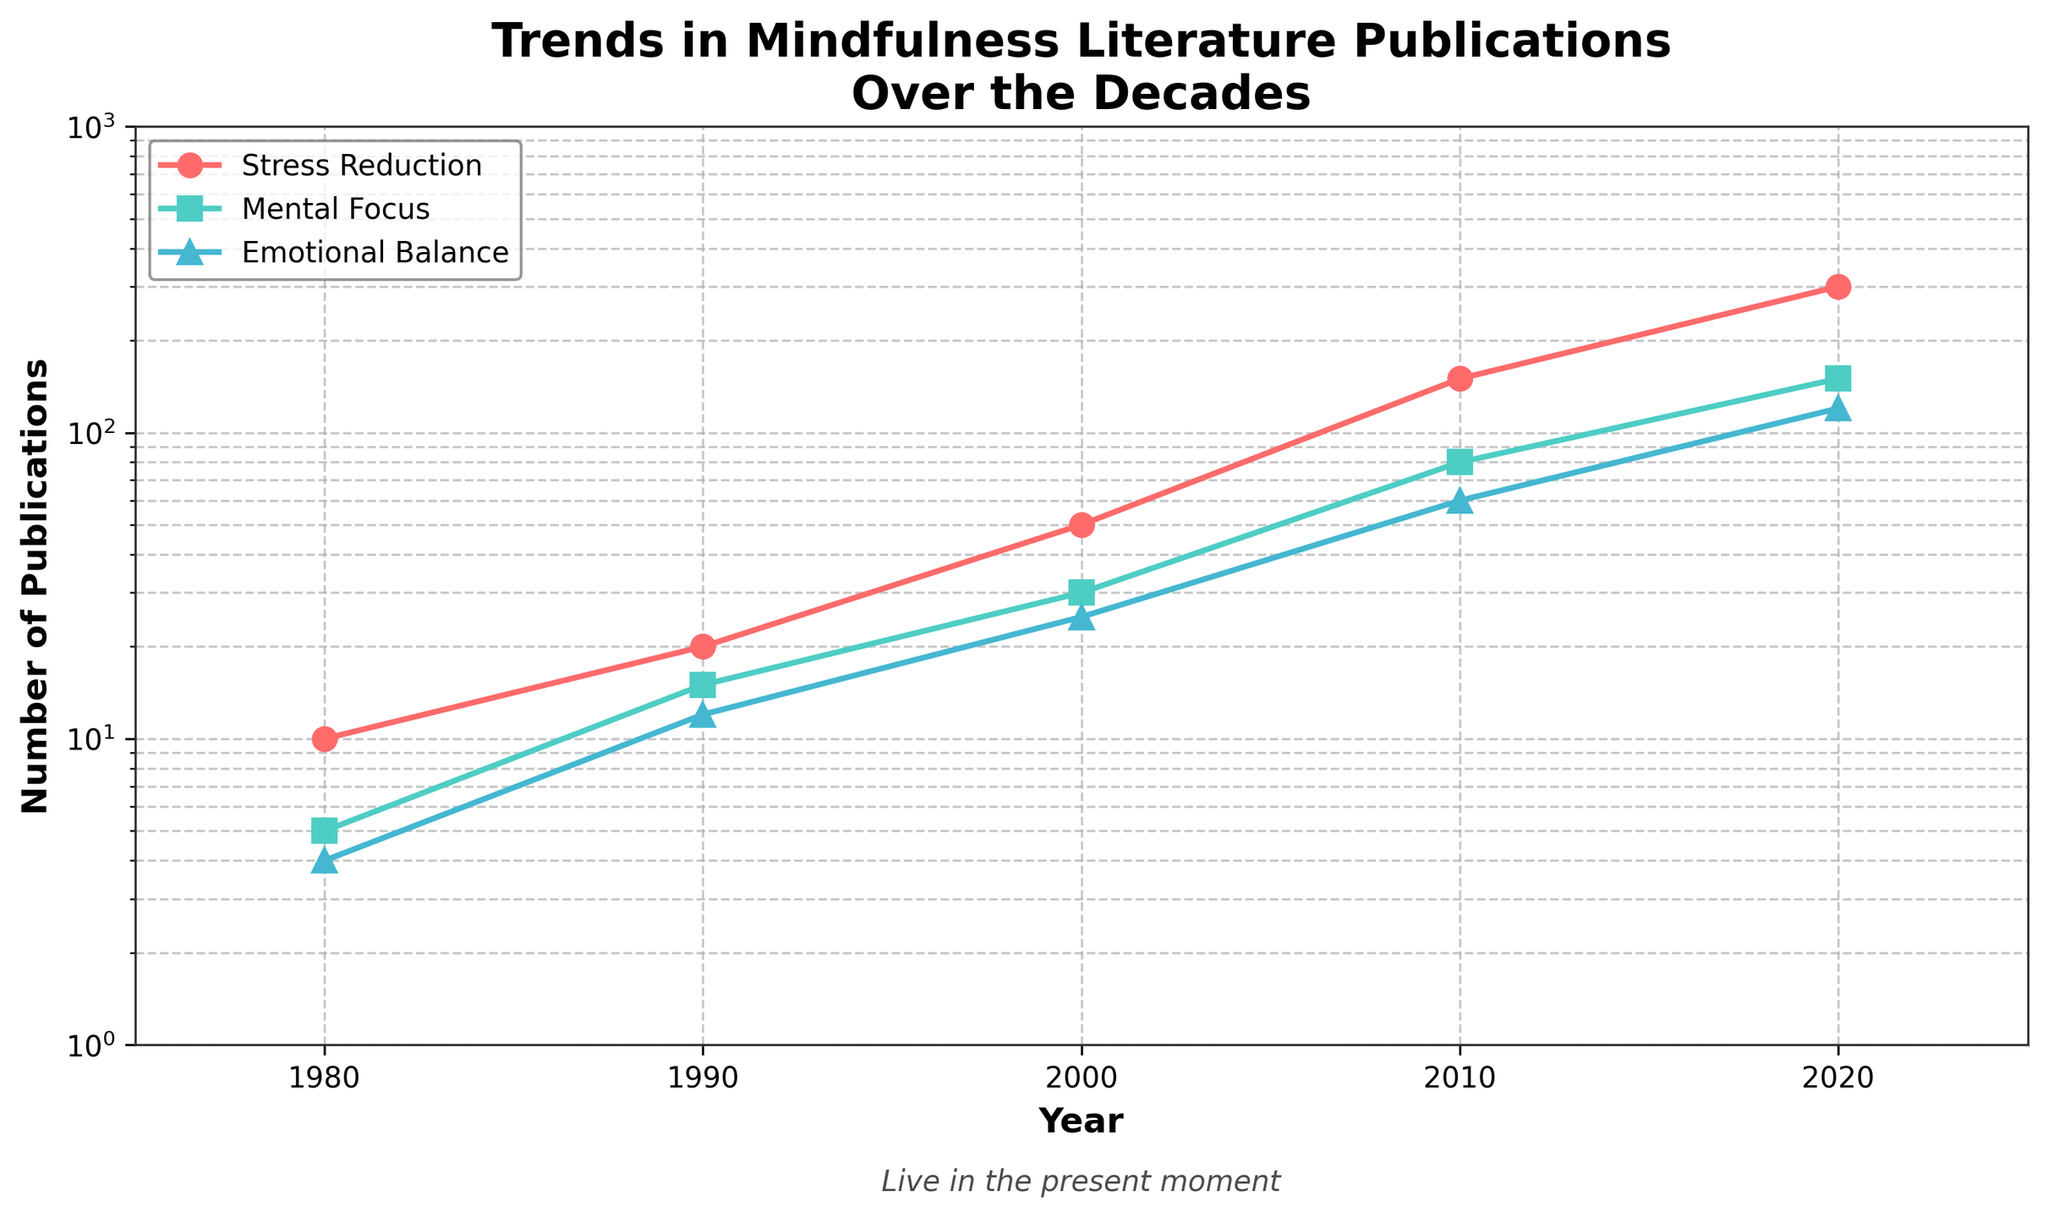What is the title of the plot? The title of the plot is located at the top center and typically written in larger, bold font.
Answer: Trends in Mindfulness Literature Publications Over the Decades Between which years does the plot show data? By examining the x-axis, which is labeled 'Year,' the range of years from the first to the last tick mark can be determined.
Answer: 1975 to 2025 How many publications were there for Stress Reduction in the year 2000? Locate the point on the Stress Reduction line that corresponds to the year 2000. The value can be read directly from this point.
Answer: 50 Which topic had the highest number of publications in 2020? Looking at the lines at the point corresponding to the year 2020, observe which line reaches the highest value on the y-axis.
Answer: Stress Reduction What is the color used for the Emotional Balance line? Notice the colored lines in the plot and identify the one labeled 'Emotional Balance'.
Answer: Blue How many topics are represented in the plot? Count the number of unique labeled lines in the legend or based on different lines in the plot.
Answer: 3 What is the approximate difference in the number of publications between Stress Reduction and Mental Focus in 2010? Locate the values corresponding to the year 2010 for both Stress Reduction and Mental Focus, then compute their difference.
Answer: 70 (150 for Stress Reduction and 80 for Mental Focus) Which decade saw the most significant increase in publications for Emotional Balance? Observe the changes in the values for Emotional Balance across consecutive decades and determine where the largest jump occurs.
Answer: 2000s Approximately how many publications were there for all topics combined in 1990? Sum the values for Stress Reduction, Mental Focus, and Emotional Balance in the year 1990.
Answer: 47 (20 + 15 + 12) How does the trend of Stress Reduction publications compare to Emotional Balance over the years? Compare the steepness and direction of the lines representing Stress Reduction and Emotional Balance. Consider periods where the rate of increase or decrease is evident.
Answer: Stress Reduction consistently increased and had steeper growth, especially in recent years 